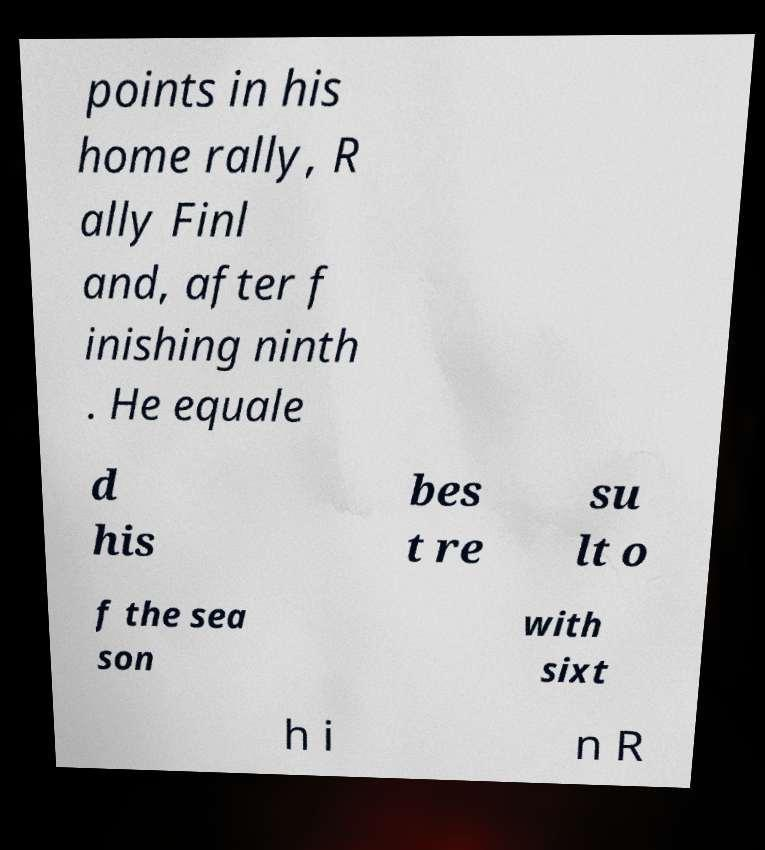There's text embedded in this image that I need extracted. Can you transcribe it verbatim? points in his home rally, R ally Finl and, after f inishing ninth . He equale d his bes t re su lt o f the sea son with sixt h i n R 